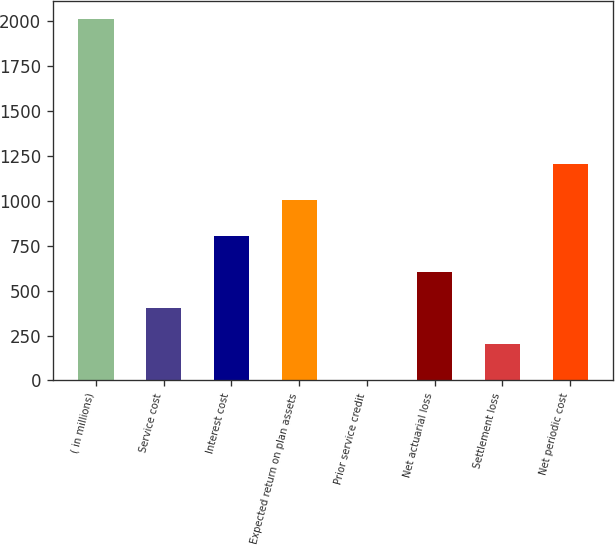Convert chart to OTSL. <chart><loc_0><loc_0><loc_500><loc_500><bar_chart><fcel>( in millions)<fcel>Service cost<fcel>Interest cost<fcel>Expected return on plan assets<fcel>Prior service credit<fcel>Net actuarial loss<fcel>Settlement loss<fcel>Net periodic cost<nl><fcel>2010<fcel>403.6<fcel>805.2<fcel>1006<fcel>2<fcel>604.4<fcel>202.8<fcel>1206.8<nl></chart> 